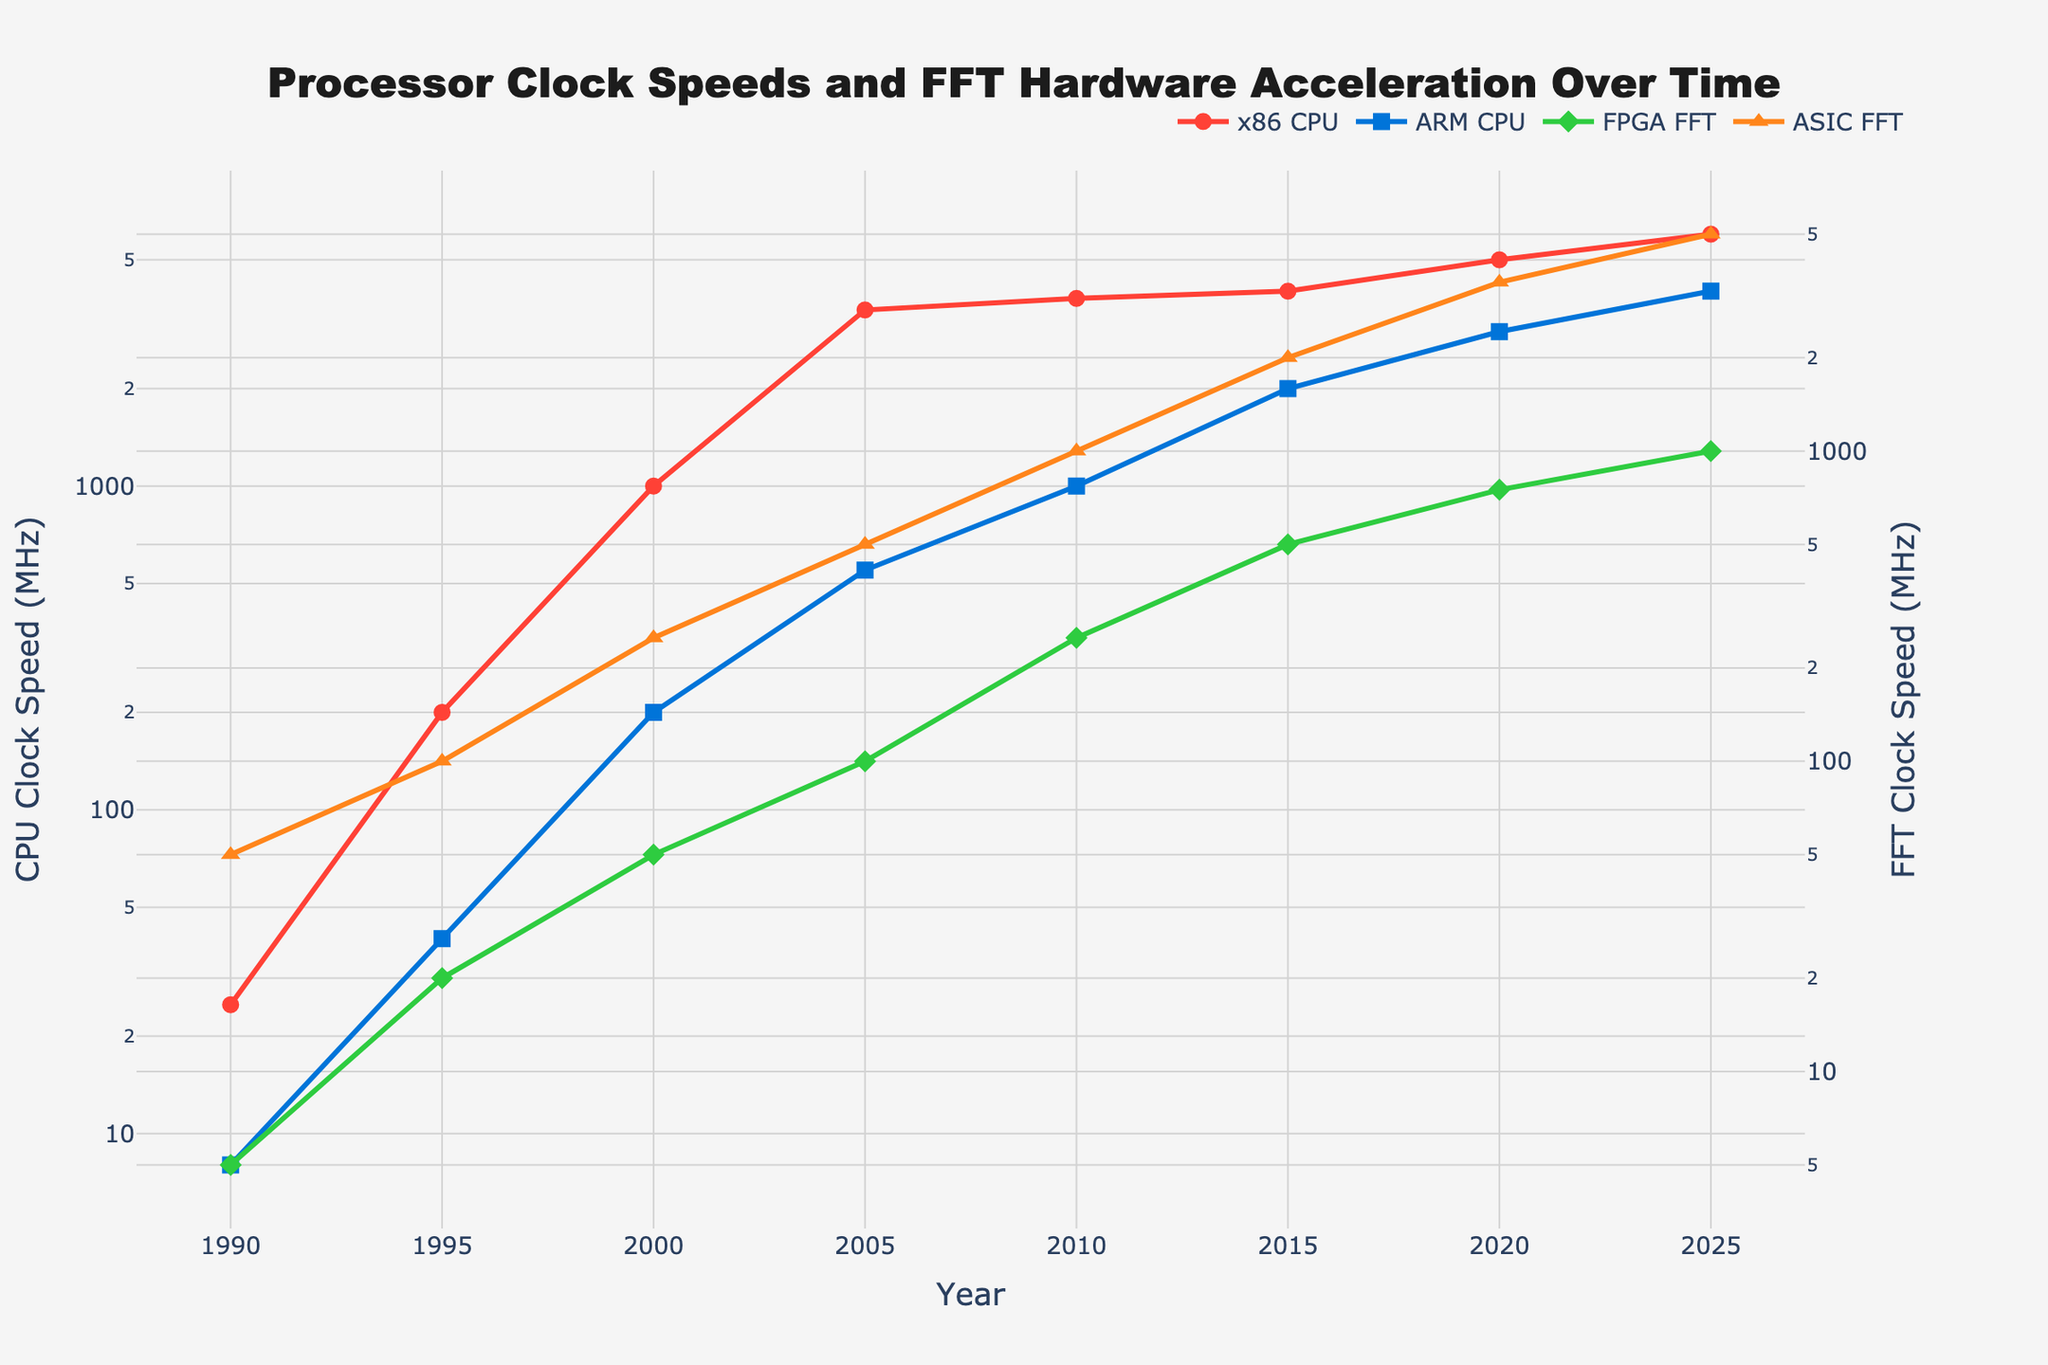What year did the x86 CPU clock speed surpass 1 GHz? Looking at the red line representing the x86 CPU, we can see it surpassed the 1 GHz mark around the year 2000.
Answer: 2000 When did the ARM CPU reach the 1000 MHz milestone? The blue line representing the ARM CPU shows it reached 1000 MHz around the year 2010.
Answer: 2010 By how much did the ASIC FFT clock speed increase between 2015 and 2020? The orange line representing ASIC FFT shows 2000 MHz in 2015 and 3500 MHz in 2020. The increase is 3500 MHz - 2000 MHz = 1500 MHz.
Answer: 1500 MHz Which hardware had the highest clock speed in 2025? In 2025, the ASIC FFT (orange line) clock speed is 5000 MHz, which is the highest among all hardware types shown in the figure.
Answer: ASIC FFT Compare the growth rate of x86 CPU and ARM CPU clock speeds from 1990 to 2025. The x86 CPU (red line) started at 25 MHz in 1990 and reached 6000 MHz by 2025, whereas the ARM CPU (blue line) started at 8 MHz in 1990 and reached 4000 MHz by 2025. Therefore, the x86 CPU grew from 25 MHz to 6000 MHz, and the ARM CPU grew from 8 MHz to 4000 MHz. The x86 CPU had a growth of 5975 MHz, while the ARM CPU had a growth of 3992 MHz. The growth rate is faster for the x86 CPU.
Answer: x86 CPU What is the difference in clock speeds between FPGA FFT and ASIC FFT in 2020? In 2020, the green line representing FPGA FFT is at 750 MHz, and the orange line representing ASIC FFT is at 3500 MHz. The difference is 3500 MHz - 750 MHz = 2750 MHz.
Answer: 2750 MHz Describe the trend of FPGA FFT clock speeds from 1990 to 2025. The green line representing FPGA FFT starts at 5 MHz in 1990 and shows steady growth to 1000 MHz in 2025. The trend indicates a gradual yet consistent increase over the years.
Answer: Steady growth What is the average clock speed of the ARM CPU for the years 2010, 2015, and 2020? The blue line shows ARM CPU clock speeds of 1000 MHz (2010), 2000 MHz (2015), and 3000 MHz (2020). The average is (1000 + 2000 + 3000) / 3 = 2000 MHz.
Answer: 2000 MHz Which year showed the first significant increase in x86 CPU clock speeds, and what was the increase? The x86 CPU clock speed, shown by the red line, had a significant increase between 1990 (25 MHz) and 1995 (200 MHz). The increase was 200 MHz - 25 MHz = 175 MHz.
Answer: 1995, 175 MHz How much faster was the ASIC FFT compared to FPGA FFT in 2015? In 2015, the orange line for ASIC FFT is at 2000 MHz, and the green line for FPGA FFT is at 500 MHz. The difference in speed is 2000 MHz - 500 MHz = 1500 MHz.
Answer: 1500 MHz 